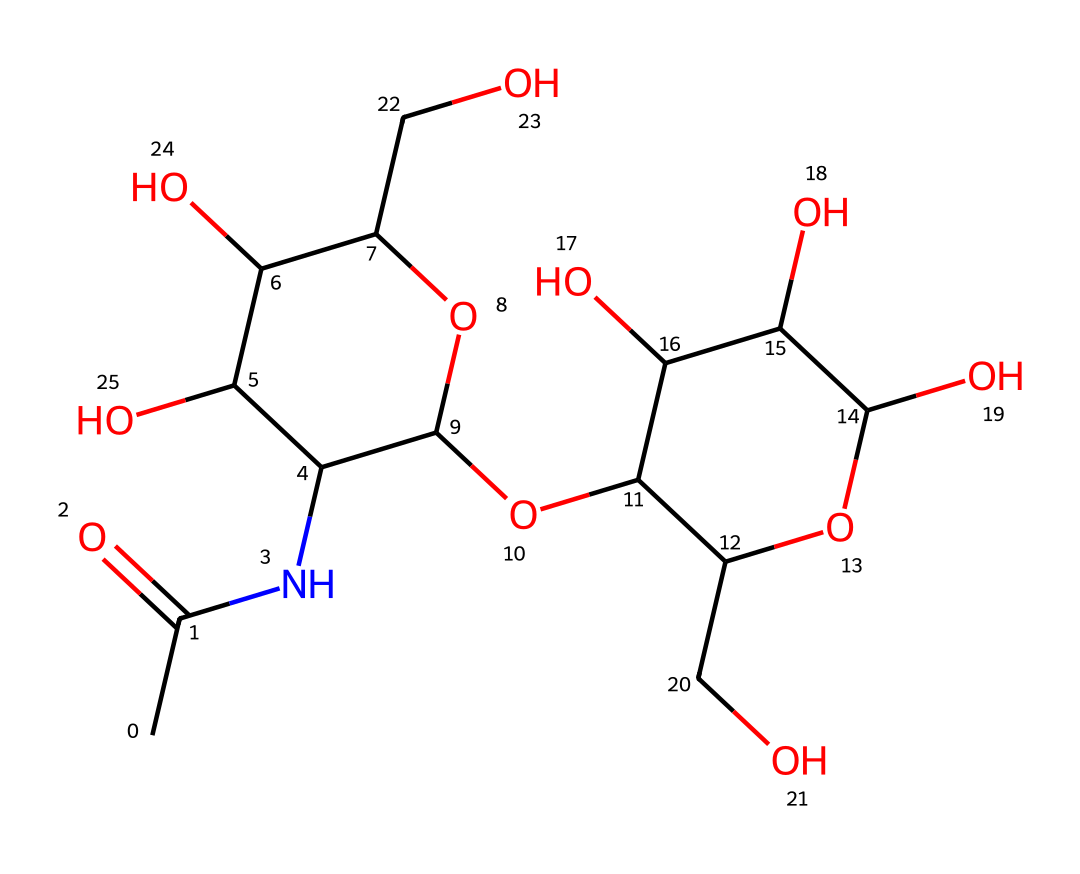how many carbon atoms are present in this structure? To determine the number of carbon atoms, we can examine the rendered chemical structure and count each carbon atom visible in the SMILES. Analyzing the structure reveals 10 carbon atoms in total.
Answer: ten what is the primary functional group in this compound? The presence of the nitrogen atom (N) attached to a carbonyl group (C=O) indicates that this compound contains an amide functional group. This is a key structural feature of hyaluronic acid.
Answer: amide which element is most likely responsible for the hydrophilic properties of hyaluronic acid? The hydroxyl groups (-OH) in the structure enhance water solubility and attract water molecules, contributing to the hydrophilic nature of hyaluronic acid. Counting the hydroxyl groups in the structure reveals that there are several present.
Answer: hydroxyl how many oxygen atoms are in this molecule? By closely inspecting the chemical structure, we can count the number of oxygen atoms present. The SMILES indicates there are 6 oxygen atoms distributed throughout the structure.
Answer: six what type of polymer is hyaluronic acid classified as? Hyaluronic acid is classified as a glycosaminoglycan, which is a type of polysaccharide consisting of repeating disaccharide units and is known for its hydrating properties in cosmetic applications.
Answer: glycosaminoglycan what is the role of hyaluronic acid in beauty products? Hyaluronic acid primarily acts as a humectant, meaning it helps to retain moisture in the skin, leading to hydration and a plump appearance. This response aligns with its chemical properties and function in cosmetics.
Answer: humectant what is the approximate molecular weight of hyaluronic acid? The molecular weight can be calculated based on the atomic composition derived from the SMILES representation. The count of atoms, namely carbon, hydrogen, nitrogen, and oxygen allows us to compute the molar mass, which is roughly around 400 kilodaltons for typical hyaluronic acid.
Answer: 400 kilodaltons 